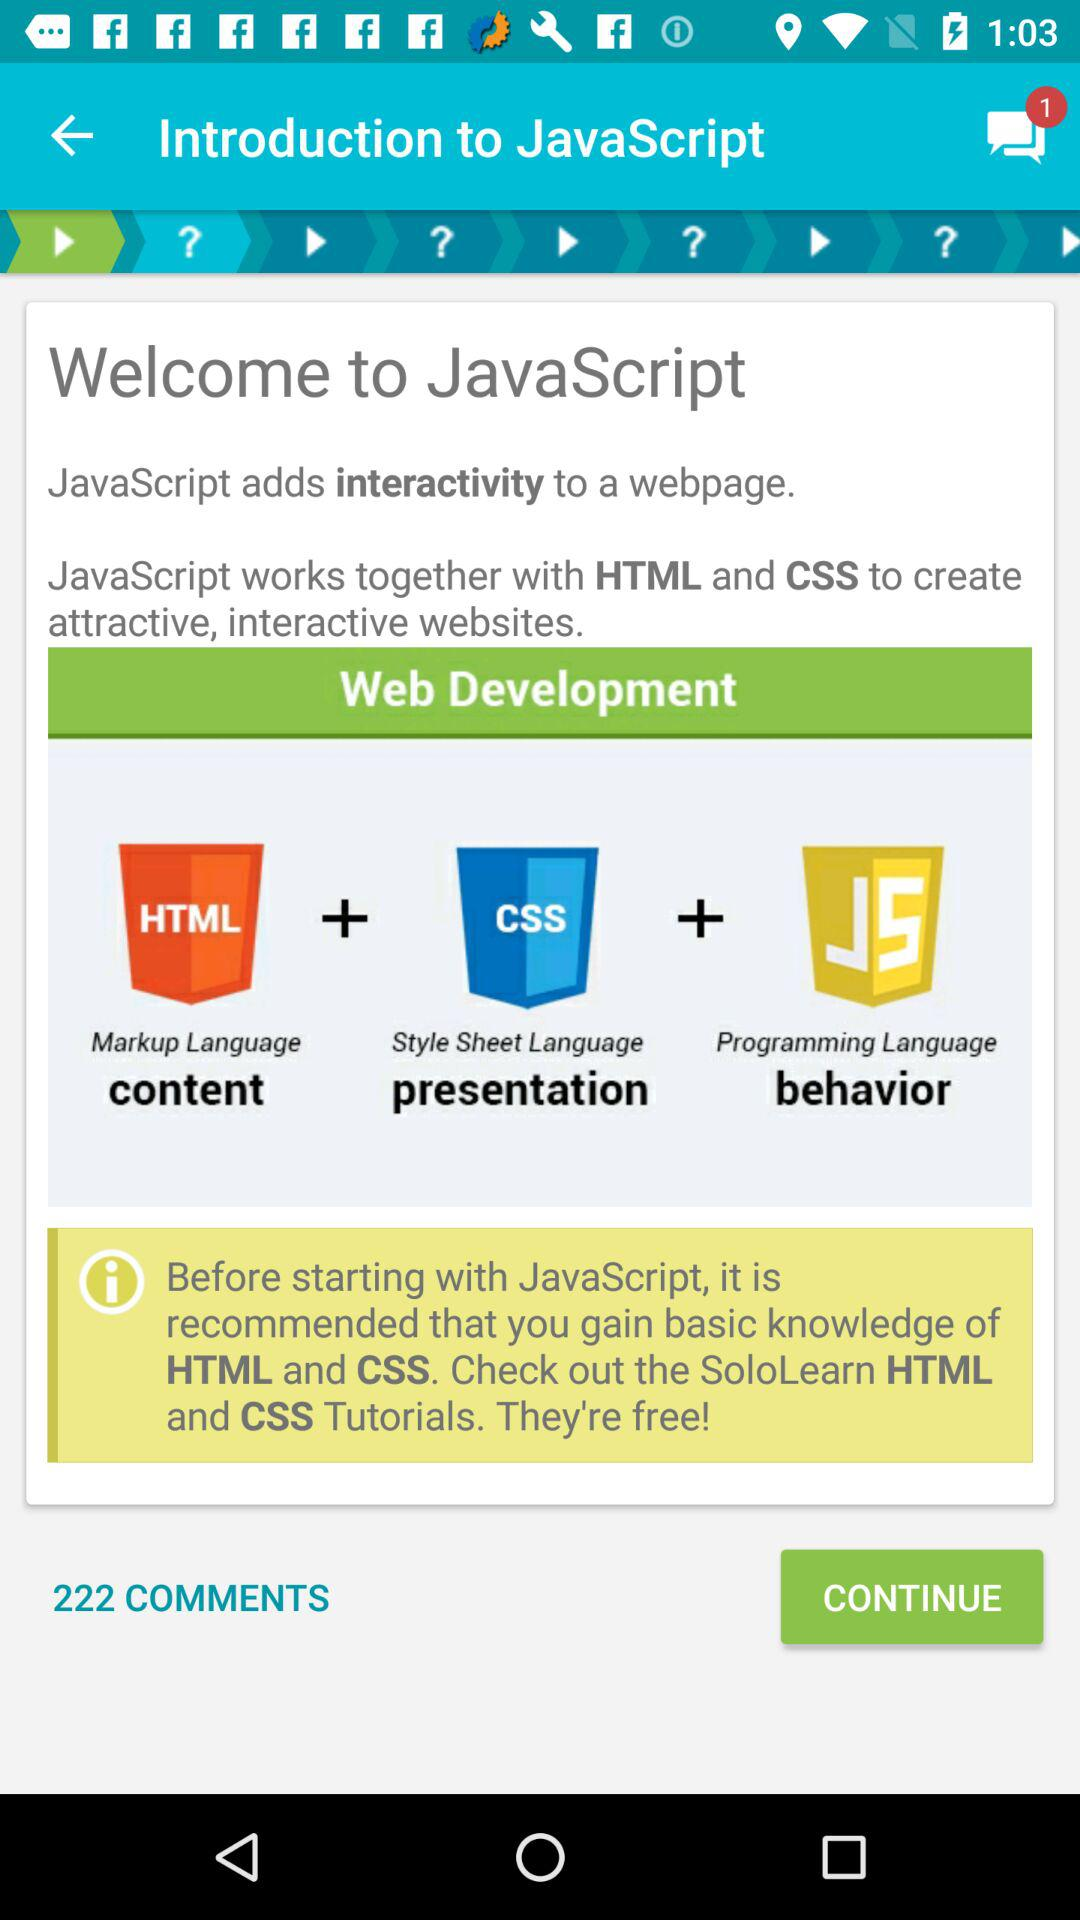How many unread chats are there? There is 1 unread chat. 